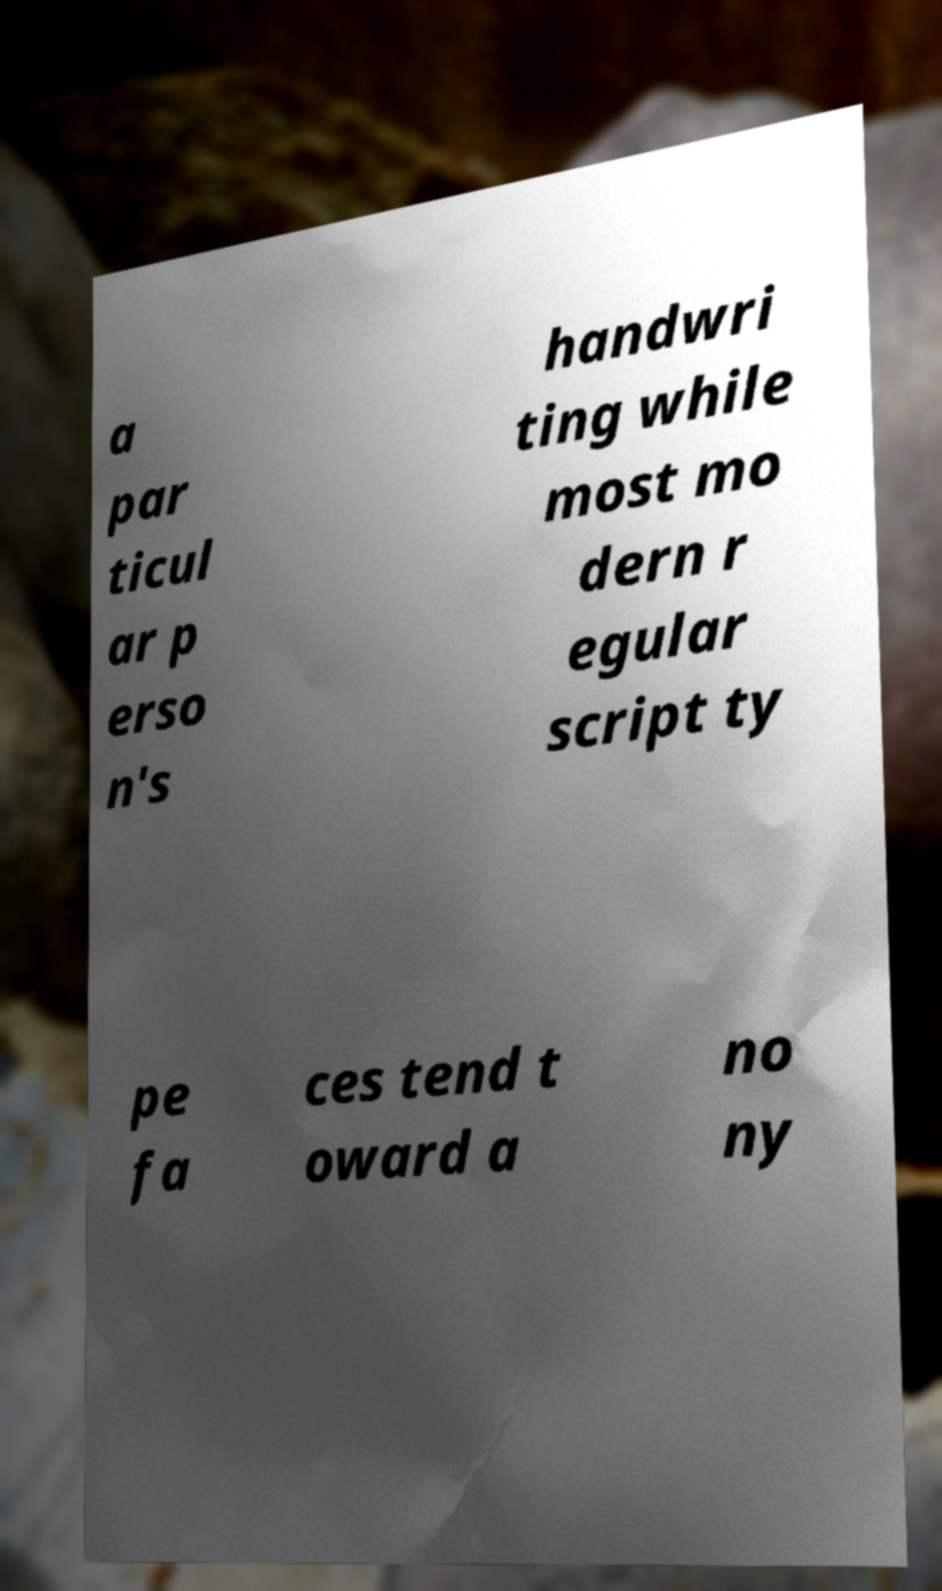Could you assist in decoding the text presented in this image and type it out clearly? a par ticul ar p erso n's handwri ting while most mo dern r egular script ty pe fa ces tend t oward a no ny 